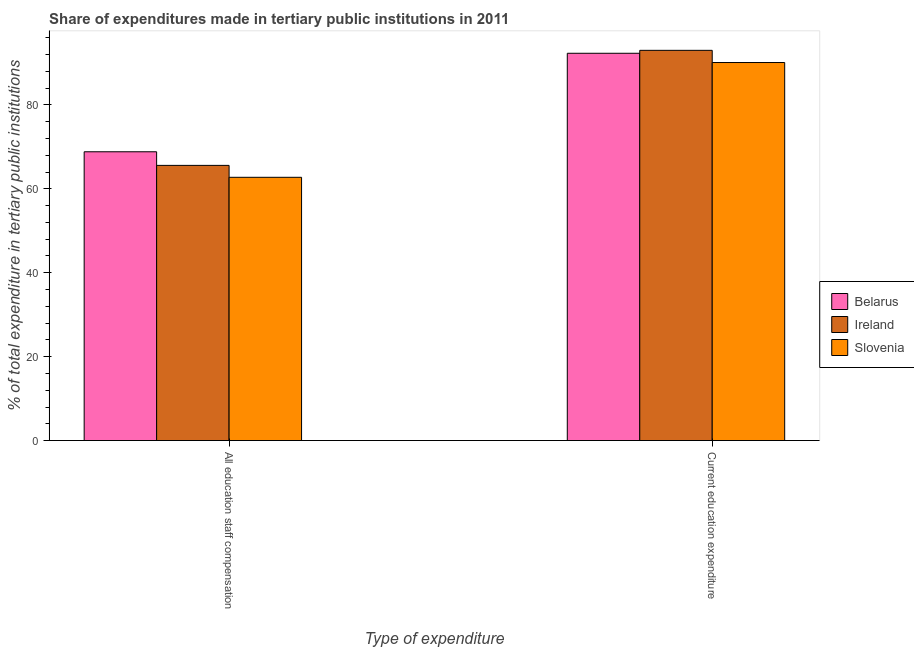Are the number of bars on each tick of the X-axis equal?
Give a very brief answer. Yes. How many bars are there on the 2nd tick from the left?
Keep it short and to the point. 3. What is the label of the 2nd group of bars from the left?
Your response must be concise. Current education expenditure. What is the expenditure in education in Ireland?
Your answer should be compact. 93. Across all countries, what is the maximum expenditure in education?
Provide a short and direct response. 93. Across all countries, what is the minimum expenditure in staff compensation?
Give a very brief answer. 62.74. In which country was the expenditure in staff compensation maximum?
Provide a short and direct response. Belarus. In which country was the expenditure in education minimum?
Your answer should be very brief. Slovenia. What is the total expenditure in staff compensation in the graph?
Ensure brevity in your answer.  197.16. What is the difference between the expenditure in staff compensation in Ireland and that in Slovenia?
Your answer should be compact. 2.84. What is the difference between the expenditure in education in Belarus and the expenditure in staff compensation in Ireland?
Keep it short and to the point. 26.72. What is the average expenditure in staff compensation per country?
Provide a short and direct response. 65.72. What is the difference between the expenditure in education and expenditure in staff compensation in Ireland?
Keep it short and to the point. 27.42. What is the ratio of the expenditure in staff compensation in Belarus to that in Ireland?
Make the answer very short. 1.05. Is the expenditure in staff compensation in Ireland less than that in Slovenia?
Your answer should be very brief. No. In how many countries, is the expenditure in staff compensation greater than the average expenditure in staff compensation taken over all countries?
Your answer should be compact. 1. What does the 1st bar from the left in All education staff compensation represents?
Offer a terse response. Belarus. What does the 2nd bar from the right in All education staff compensation represents?
Ensure brevity in your answer.  Ireland. How many bars are there?
Provide a succinct answer. 6. How many countries are there in the graph?
Provide a short and direct response. 3. Are the values on the major ticks of Y-axis written in scientific E-notation?
Keep it short and to the point. No. Does the graph contain any zero values?
Keep it short and to the point. No. Where does the legend appear in the graph?
Offer a terse response. Center right. How are the legend labels stacked?
Offer a terse response. Vertical. What is the title of the graph?
Provide a short and direct response. Share of expenditures made in tertiary public institutions in 2011. Does "OECD members" appear as one of the legend labels in the graph?
Provide a succinct answer. No. What is the label or title of the X-axis?
Offer a terse response. Type of expenditure. What is the label or title of the Y-axis?
Offer a very short reply. % of total expenditure in tertiary public institutions. What is the % of total expenditure in tertiary public institutions in Belarus in All education staff compensation?
Offer a very short reply. 68.83. What is the % of total expenditure in tertiary public institutions of Ireland in All education staff compensation?
Keep it short and to the point. 65.59. What is the % of total expenditure in tertiary public institutions in Slovenia in All education staff compensation?
Provide a short and direct response. 62.74. What is the % of total expenditure in tertiary public institutions of Belarus in Current education expenditure?
Your answer should be very brief. 92.3. What is the % of total expenditure in tertiary public institutions in Ireland in Current education expenditure?
Provide a succinct answer. 93. What is the % of total expenditure in tertiary public institutions in Slovenia in Current education expenditure?
Give a very brief answer. 90.1. Across all Type of expenditure, what is the maximum % of total expenditure in tertiary public institutions of Belarus?
Offer a terse response. 92.3. Across all Type of expenditure, what is the maximum % of total expenditure in tertiary public institutions of Ireland?
Make the answer very short. 93. Across all Type of expenditure, what is the maximum % of total expenditure in tertiary public institutions in Slovenia?
Your response must be concise. 90.1. Across all Type of expenditure, what is the minimum % of total expenditure in tertiary public institutions in Belarus?
Your answer should be very brief. 68.83. Across all Type of expenditure, what is the minimum % of total expenditure in tertiary public institutions of Ireland?
Make the answer very short. 65.59. Across all Type of expenditure, what is the minimum % of total expenditure in tertiary public institutions in Slovenia?
Provide a succinct answer. 62.74. What is the total % of total expenditure in tertiary public institutions in Belarus in the graph?
Ensure brevity in your answer.  161.13. What is the total % of total expenditure in tertiary public institutions in Ireland in the graph?
Offer a terse response. 158.59. What is the total % of total expenditure in tertiary public institutions of Slovenia in the graph?
Your answer should be compact. 152.84. What is the difference between the % of total expenditure in tertiary public institutions of Belarus in All education staff compensation and that in Current education expenditure?
Your answer should be very brief. -23.47. What is the difference between the % of total expenditure in tertiary public institutions of Ireland in All education staff compensation and that in Current education expenditure?
Provide a short and direct response. -27.42. What is the difference between the % of total expenditure in tertiary public institutions of Slovenia in All education staff compensation and that in Current education expenditure?
Make the answer very short. -27.35. What is the difference between the % of total expenditure in tertiary public institutions in Belarus in All education staff compensation and the % of total expenditure in tertiary public institutions in Ireland in Current education expenditure?
Give a very brief answer. -24.18. What is the difference between the % of total expenditure in tertiary public institutions in Belarus in All education staff compensation and the % of total expenditure in tertiary public institutions in Slovenia in Current education expenditure?
Make the answer very short. -21.27. What is the difference between the % of total expenditure in tertiary public institutions in Ireland in All education staff compensation and the % of total expenditure in tertiary public institutions in Slovenia in Current education expenditure?
Offer a terse response. -24.51. What is the average % of total expenditure in tertiary public institutions of Belarus per Type of expenditure?
Ensure brevity in your answer.  80.57. What is the average % of total expenditure in tertiary public institutions of Ireland per Type of expenditure?
Your response must be concise. 79.3. What is the average % of total expenditure in tertiary public institutions of Slovenia per Type of expenditure?
Provide a succinct answer. 76.42. What is the difference between the % of total expenditure in tertiary public institutions in Belarus and % of total expenditure in tertiary public institutions in Ireland in All education staff compensation?
Your response must be concise. 3.24. What is the difference between the % of total expenditure in tertiary public institutions of Belarus and % of total expenditure in tertiary public institutions of Slovenia in All education staff compensation?
Your answer should be very brief. 6.08. What is the difference between the % of total expenditure in tertiary public institutions of Ireland and % of total expenditure in tertiary public institutions of Slovenia in All education staff compensation?
Offer a terse response. 2.84. What is the difference between the % of total expenditure in tertiary public institutions of Belarus and % of total expenditure in tertiary public institutions of Ireland in Current education expenditure?
Keep it short and to the point. -0.7. What is the difference between the % of total expenditure in tertiary public institutions of Belarus and % of total expenditure in tertiary public institutions of Slovenia in Current education expenditure?
Your response must be concise. 2.2. What is the difference between the % of total expenditure in tertiary public institutions in Ireland and % of total expenditure in tertiary public institutions in Slovenia in Current education expenditure?
Your answer should be very brief. 2.9. What is the ratio of the % of total expenditure in tertiary public institutions in Belarus in All education staff compensation to that in Current education expenditure?
Offer a terse response. 0.75. What is the ratio of the % of total expenditure in tertiary public institutions of Ireland in All education staff compensation to that in Current education expenditure?
Provide a succinct answer. 0.71. What is the ratio of the % of total expenditure in tertiary public institutions of Slovenia in All education staff compensation to that in Current education expenditure?
Provide a short and direct response. 0.7. What is the difference between the highest and the second highest % of total expenditure in tertiary public institutions of Belarus?
Your response must be concise. 23.47. What is the difference between the highest and the second highest % of total expenditure in tertiary public institutions of Ireland?
Your answer should be compact. 27.42. What is the difference between the highest and the second highest % of total expenditure in tertiary public institutions in Slovenia?
Provide a succinct answer. 27.35. What is the difference between the highest and the lowest % of total expenditure in tertiary public institutions in Belarus?
Ensure brevity in your answer.  23.47. What is the difference between the highest and the lowest % of total expenditure in tertiary public institutions of Ireland?
Your answer should be very brief. 27.42. What is the difference between the highest and the lowest % of total expenditure in tertiary public institutions in Slovenia?
Keep it short and to the point. 27.35. 